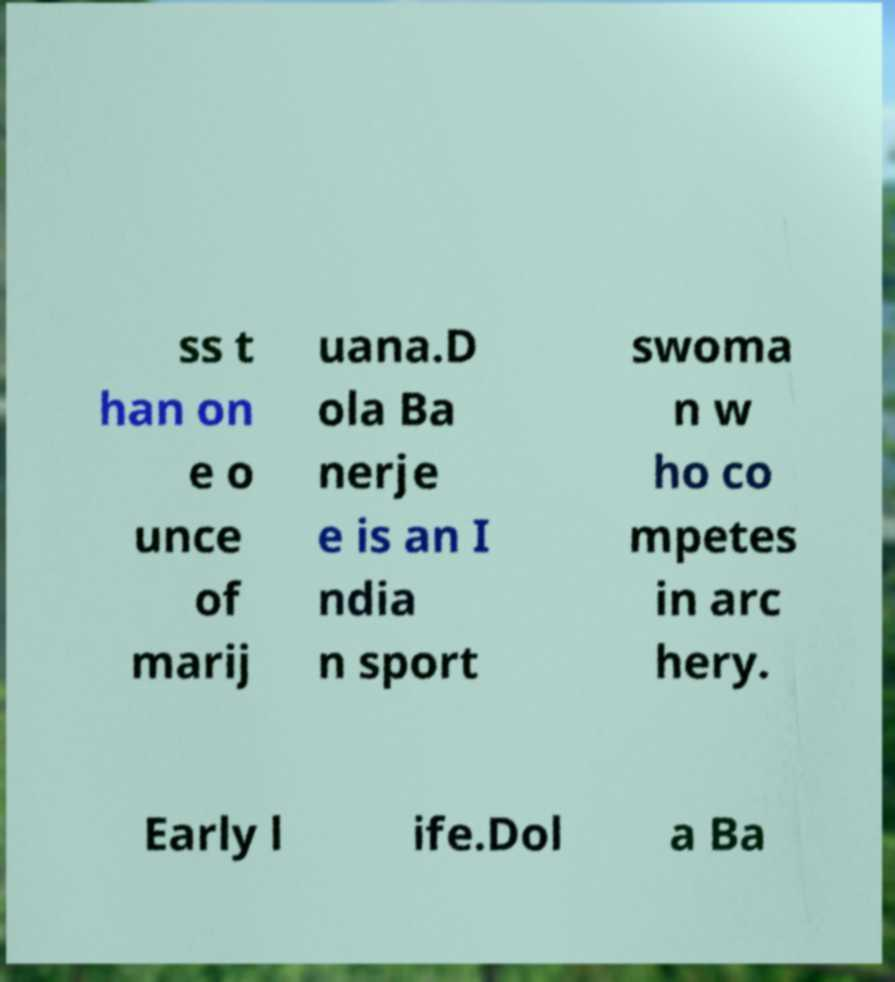What messages or text are displayed in this image? I need them in a readable, typed format. ss t han on e o unce of marij uana.D ola Ba nerje e is an I ndia n sport swoma n w ho co mpetes in arc hery. Early l ife.Dol a Ba 